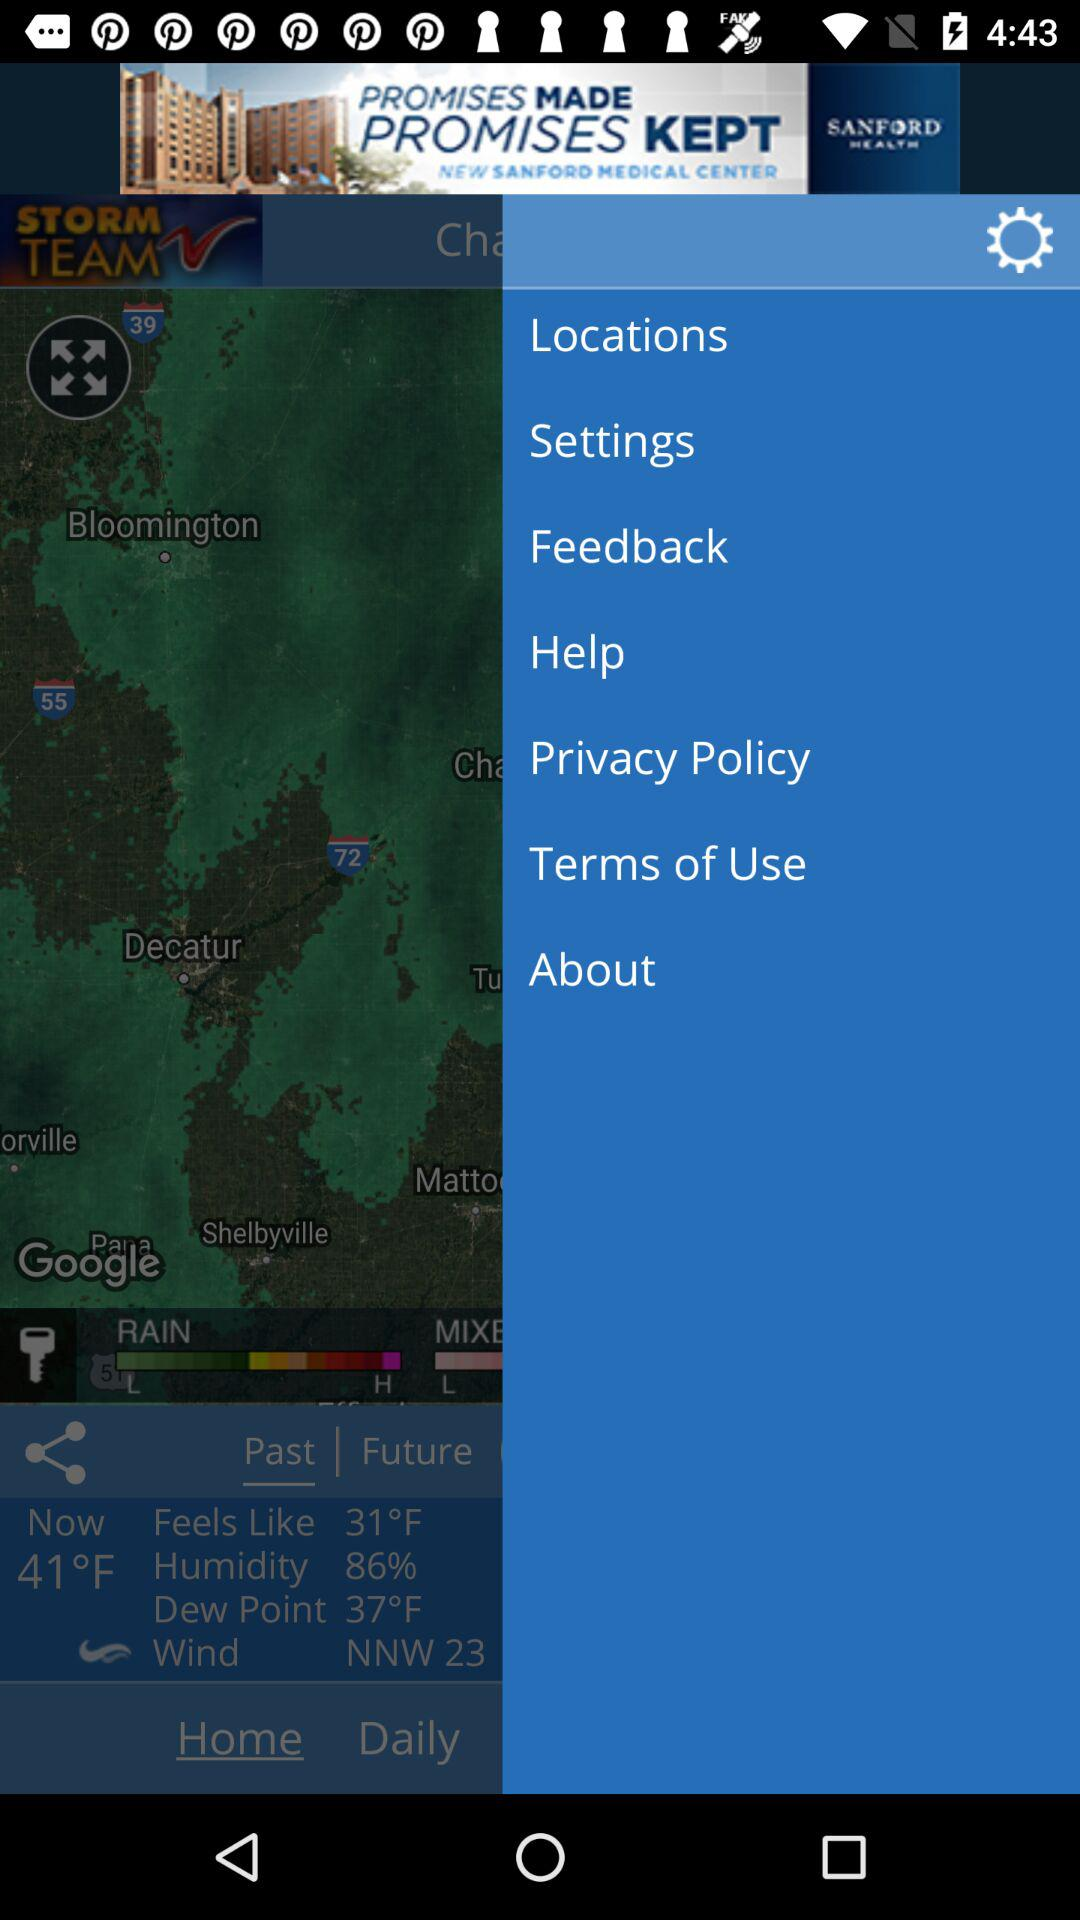How many degrees Fahrenheit is the difference between the feels like temperature and the dew point?
Answer the question using a single word or phrase. 6 